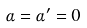<formula> <loc_0><loc_0><loc_500><loc_500>\alpha = \alpha ^ { \prime } = 0</formula> 